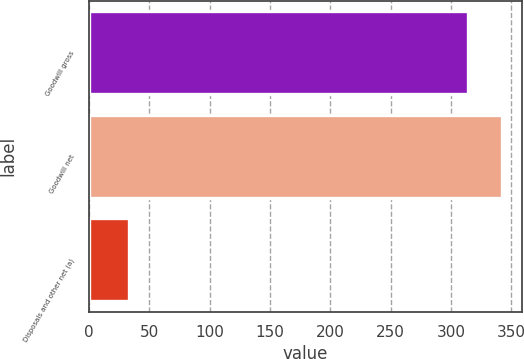Convert chart to OTSL. <chart><loc_0><loc_0><loc_500><loc_500><bar_chart><fcel>Goodwill gross<fcel>Goodwill net<fcel>Disposals and other net (a)<nl><fcel>314<fcel>342.1<fcel>33<nl></chart> 